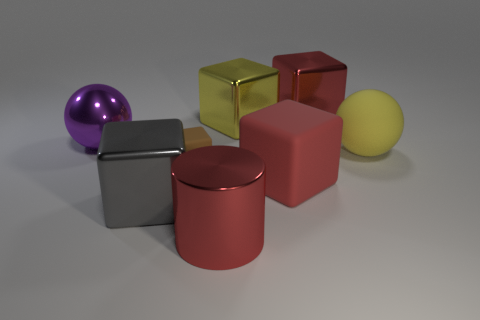Subtract all brown blocks. How many blocks are left? 4 Subtract all small blocks. How many blocks are left? 4 Subtract 1 cubes. How many cubes are left? 4 Subtract all cyan blocks. Subtract all green cylinders. How many blocks are left? 5 Add 1 small rubber objects. How many objects exist? 9 Subtract all balls. How many objects are left? 6 Add 6 rubber cubes. How many rubber cubes exist? 8 Subtract 1 yellow cubes. How many objects are left? 7 Subtract all spheres. Subtract all cyan metal cylinders. How many objects are left? 6 Add 7 yellow balls. How many yellow balls are left? 8 